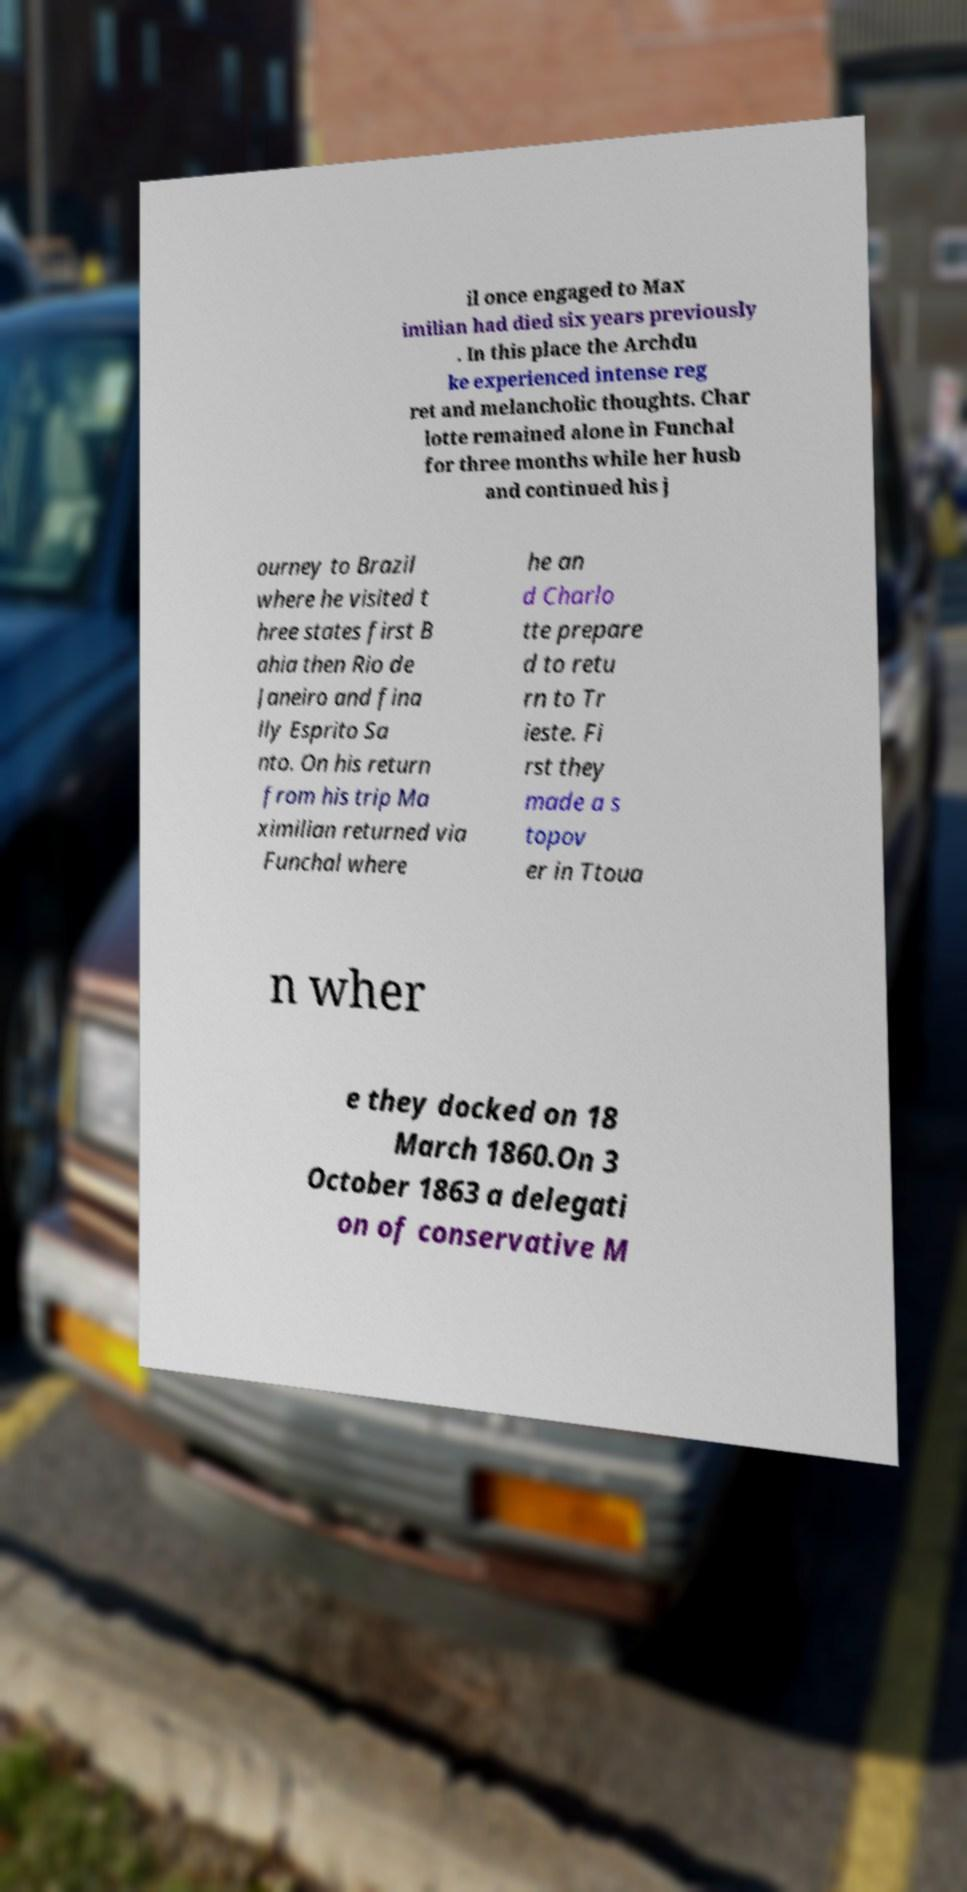Could you assist in decoding the text presented in this image and type it out clearly? il once engaged to Max imilian had died six years previously . In this place the Archdu ke experienced intense reg ret and melancholic thoughts. Char lotte remained alone in Funchal for three months while her husb and continued his j ourney to Brazil where he visited t hree states first B ahia then Rio de Janeiro and fina lly Esprito Sa nto. On his return from his trip Ma ximilian returned via Funchal where he an d Charlo tte prepare d to retu rn to Tr ieste. Fi rst they made a s topov er in Ttoua n wher e they docked on 18 March 1860.On 3 October 1863 a delegati on of conservative M 